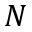Convert formula to latex. <formula><loc_0><loc_0><loc_500><loc_500>N</formula> 